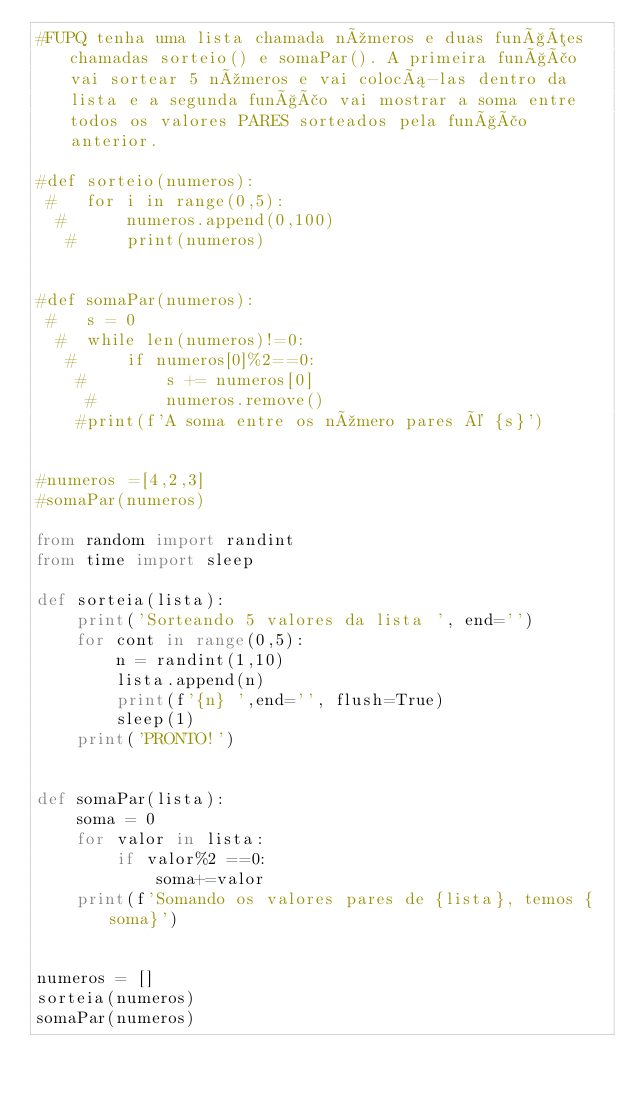Convert code to text. <code><loc_0><loc_0><loc_500><loc_500><_Python_>#FUPQ tenha uma lista chamada números e duas funções chamadas sorteio() e somaPar(). A primeira função vai sortear 5 números e vai colocá-las dentro da lista e a segunda função vai mostrar a soma entre todos os valores PARES sorteados pela função anterior.

#def sorteio(numeros):
 #   for i in range(0,5):
  #      numeros.append(0,100)
   #     print(numeros)


#def somaPar(numeros):
 #   s = 0
  #  while len(numeros)!=0:
   #     if numeros[0]%2==0:
    #        s += numeros[0]
     #       numeros.remove()
    #print(f'A soma entre os número pares é {s}')


#numeros =[4,2,3]
#somaPar(numeros)

from random import randint
from time import sleep

def sorteia(lista):
    print('Sorteando 5 valores da lista ', end='')
    for cont in range(0,5):
        n = randint(1,10)
        lista.append(n)
        print(f'{n} ',end='', flush=True)
        sleep(1)
    print('PRONTO!')


def somaPar(lista):
    soma = 0
    for valor in lista:
        if valor%2 ==0:
            soma+=valor
    print(f'Somando os valores pares de {lista}, temos {soma}')


numeros = []
sorteia(numeros)
somaPar(numeros)








</code> 